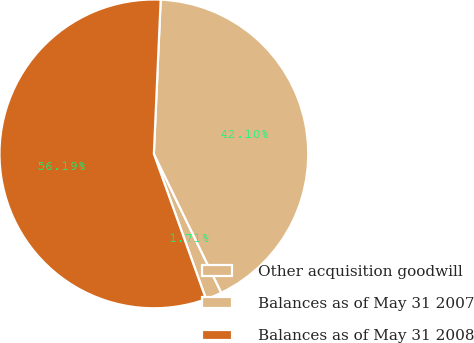Convert chart to OTSL. <chart><loc_0><loc_0><loc_500><loc_500><pie_chart><fcel>Other acquisition goodwill<fcel>Balances as of May 31 2007<fcel>Balances as of May 31 2008<nl><fcel>1.71%<fcel>42.1%<fcel>56.19%<nl></chart> 